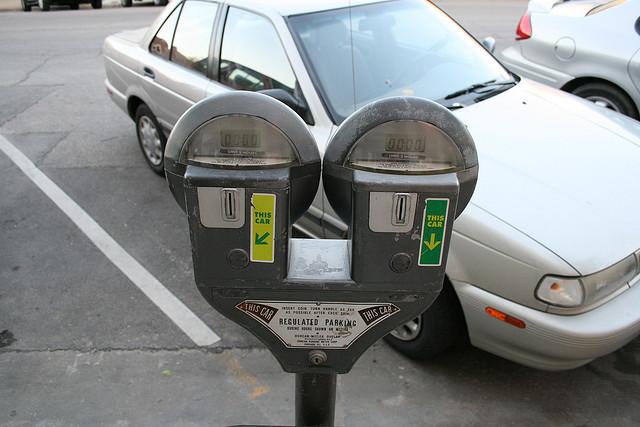Does the main car use the green or yellow meter?
Write a very short answer. Green. What does the yellow tag say?
Be succinct. This car. How many parking meters?
Keep it brief. 2. Does the right meter have any time left on it?
Concise answer only. No. 